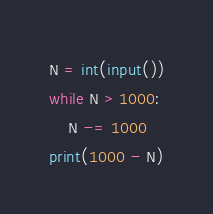Convert code to text. <code><loc_0><loc_0><loc_500><loc_500><_Python_>N = int(input())
while N > 1000:
    N -= 1000
print(1000 - N)</code> 